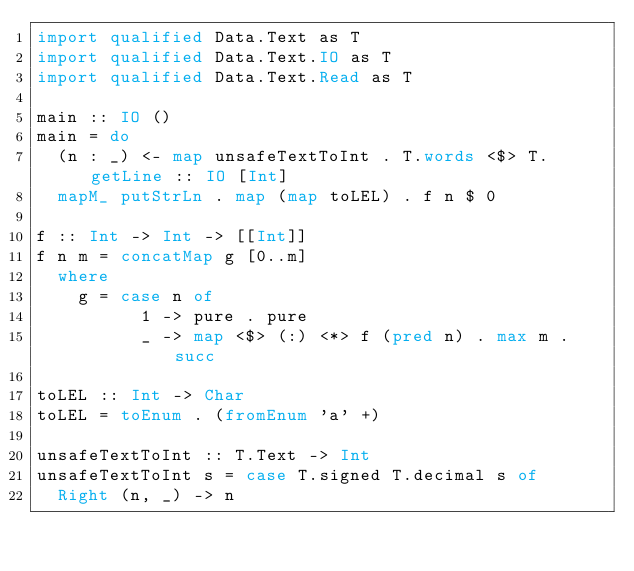Convert code to text. <code><loc_0><loc_0><loc_500><loc_500><_Haskell_>import qualified Data.Text as T
import qualified Data.Text.IO as T
import qualified Data.Text.Read as T

main :: IO ()
main = do
  (n : _) <- map unsafeTextToInt . T.words <$> T.getLine :: IO [Int]
  mapM_ putStrLn . map (map toLEL) . f n $ 0

f :: Int -> Int -> [[Int]]
f n m = concatMap g [0..m]
  where
    g = case n of
          1 -> pure . pure
          _ -> map <$> (:) <*> f (pred n) . max m . succ

toLEL :: Int -> Char
toLEL = toEnum . (fromEnum 'a' +)

unsafeTextToInt :: T.Text -> Int
unsafeTextToInt s = case T.signed T.decimal s of
  Right (n, _) -> n
</code> 